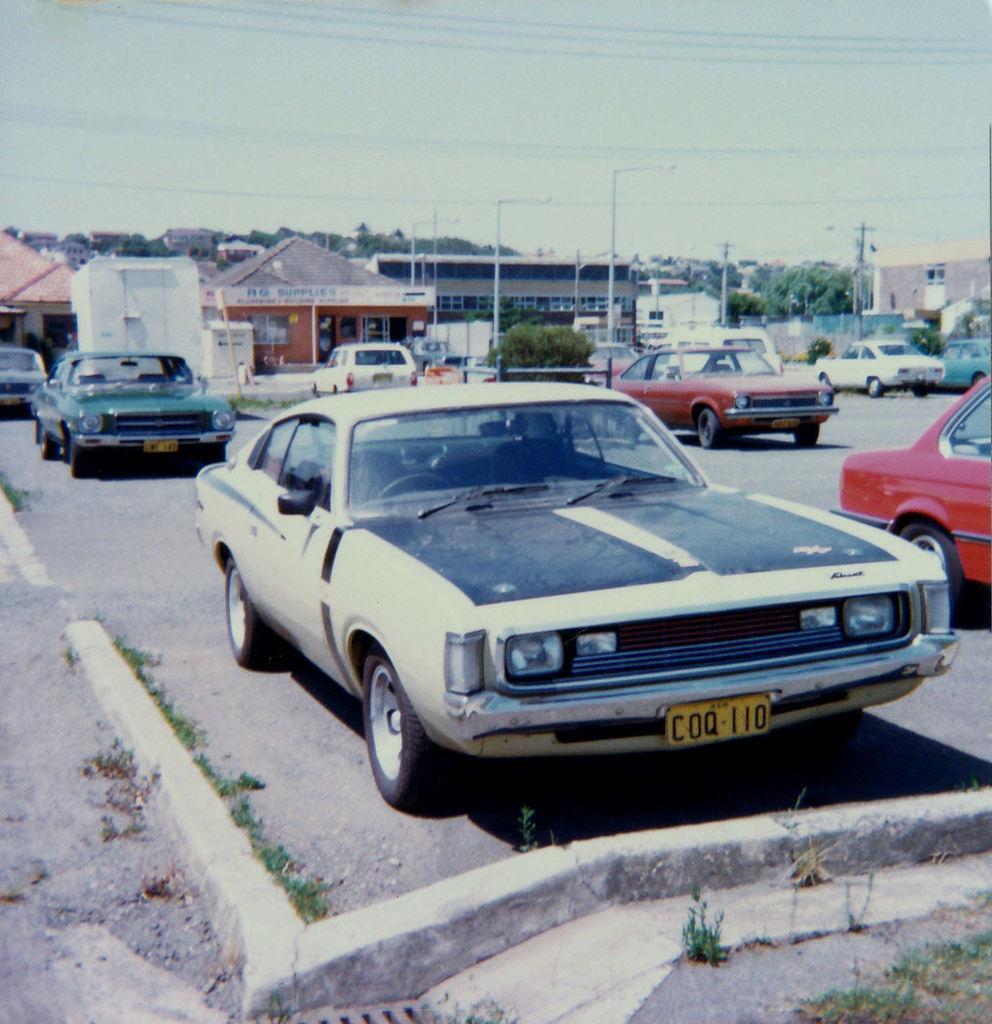What can be seen on the road in the image? There are cars parked on the road in the image. What is visible in the distance behind the parked cars? There are buildings and electrical poles visible in the background of the image. What type of list is being used on the desk in the image? There is no desk or list present in the image; it features parked cars on the road and buildings and electrical poles in the background. 